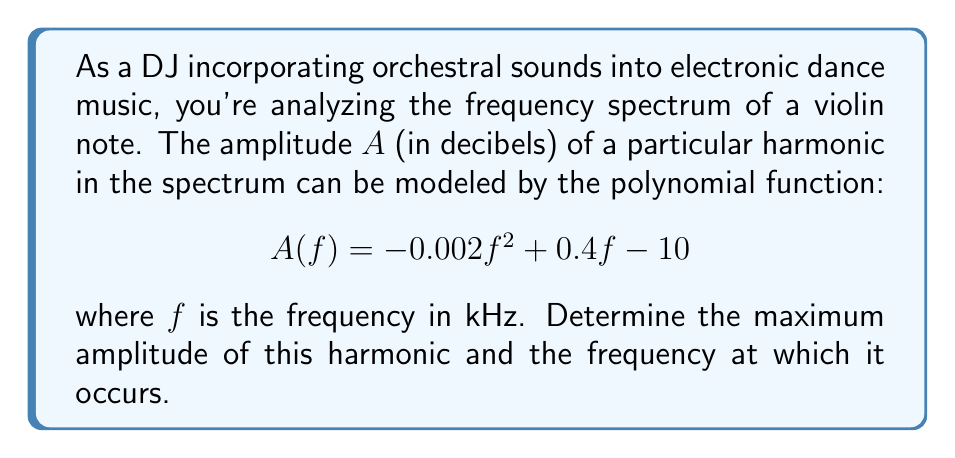Give your solution to this math problem. To find the maximum amplitude and the frequency at which it occurs, we need to follow these steps:

1) The maximum point of a quadratic function occurs at the vertex of the parabola. For a quadratic function in the form $y = ax^2 + bx + c$, the x-coordinate of the vertex is given by $x = -\frac{b}{2a}$.

2) In our function $A(f) = -0.002f^2 + 0.4f - 10$, we have:
   $a = -0.002$
   $b = 0.4$
   $c = -10$

3) Let's calculate the frequency at which the maximum occurs:

   $f = -\frac{b}{2a} = -\frac{0.4}{2(-0.002)} = \frac{0.4}{0.004} = 100$ kHz

4) To find the maximum amplitude, we substitute this frequency back into our original function:

   $A(100) = -0.002(100)^2 + 0.4(100) - 10$
           $= -20 + 40 - 10$
           $= 10$ dB

5) Therefore, the maximum amplitude is 10 dB and it occurs at a frequency of 100 kHz.
Answer: The maximum amplitude is 10 dB, occurring at a frequency of 100 kHz. 